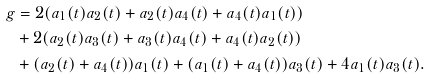<formula> <loc_0><loc_0><loc_500><loc_500>g & = 2 ( a _ { 1 } ( t ) a _ { 2 } ( t ) + a _ { 2 } ( t ) a _ { 4 } ( t ) + a _ { 4 } ( t ) a _ { 1 } ( t ) ) \\ & + 2 ( a _ { 2 } ( t ) a _ { 3 } ( t ) + a _ { 3 } ( t ) a _ { 4 } ( t ) + a _ { 4 } ( t ) a _ { 2 } ( t ) ) \\ & + ( a _ { 2 } ( t ) + a _ { 4 } ( t ) ) a _ { 1 } ( t ) + ( a _ { 1 } ( t ) + a _ { 4 } ( t ) ) a _ { 3 } ( t ) + 4 a _ { 1 } ( t ) a _ { 3 } ( t ) .</formula> 